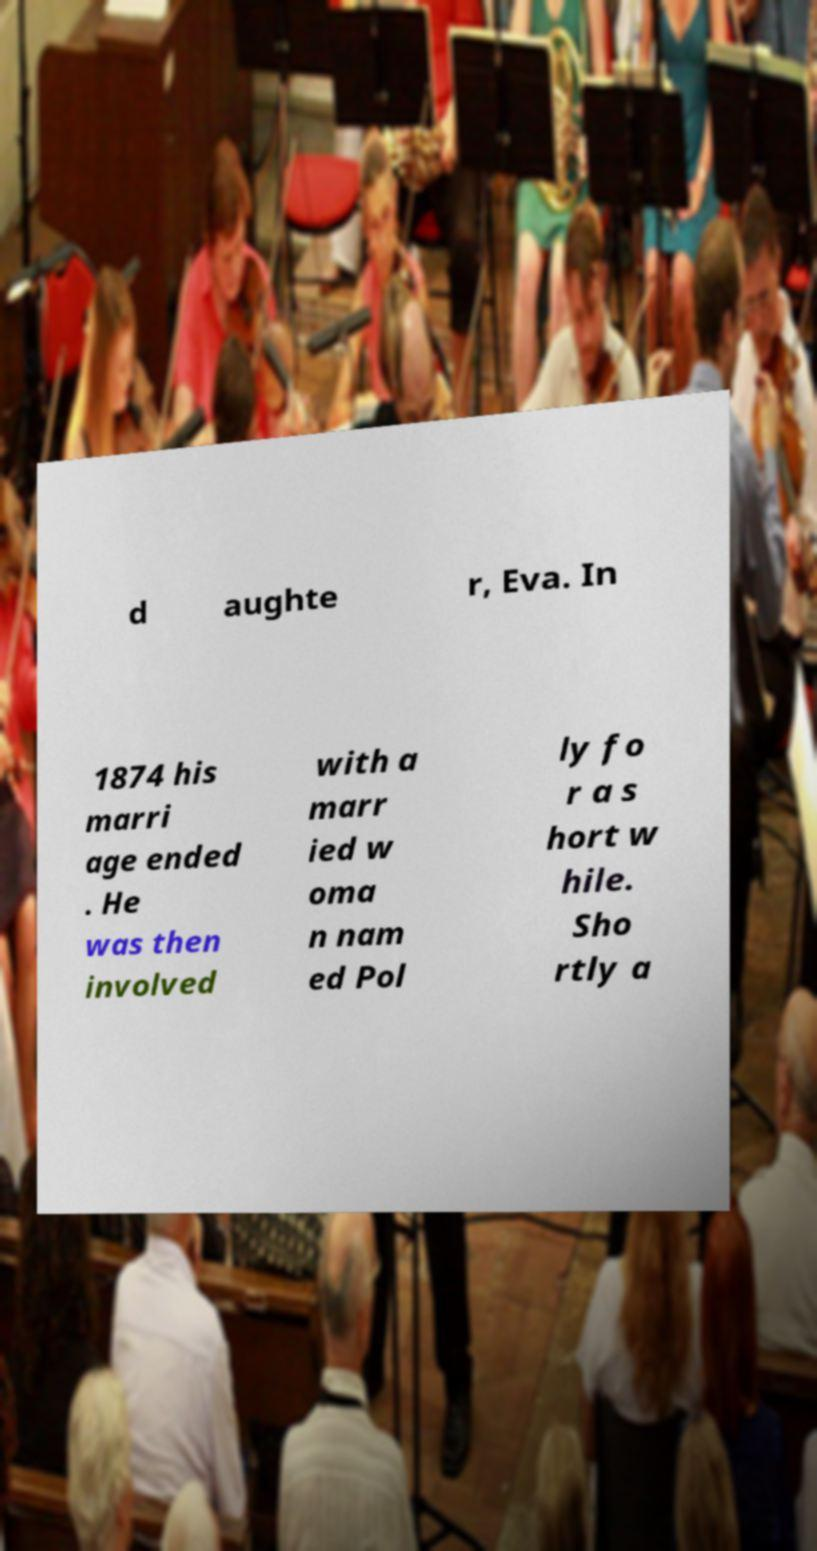Please identify and transcribe the text found in this image. d aughte r, Eva. In 1874 his marri age ended . He was then involved with a marr ied w oma n nam ed Pol ly fo r a s hort w hile. Sho rtly a 